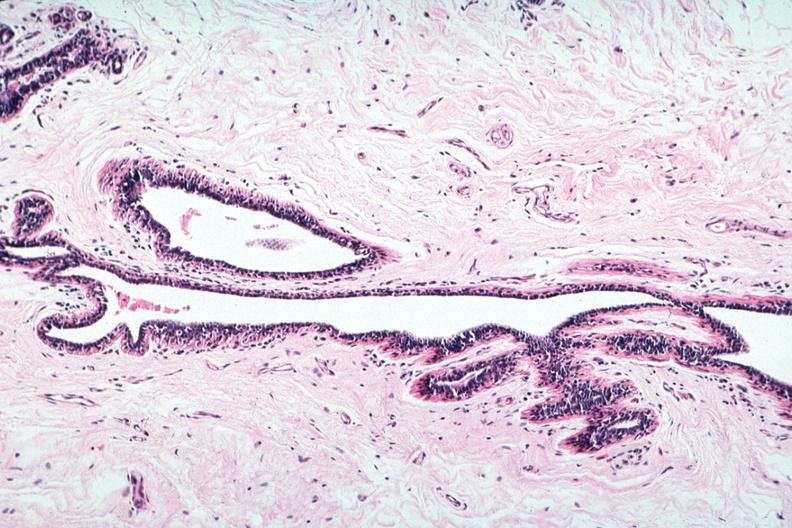what does this image show?
Answer the question using a single word or phrase. Normal duct in postmenopausal woman 